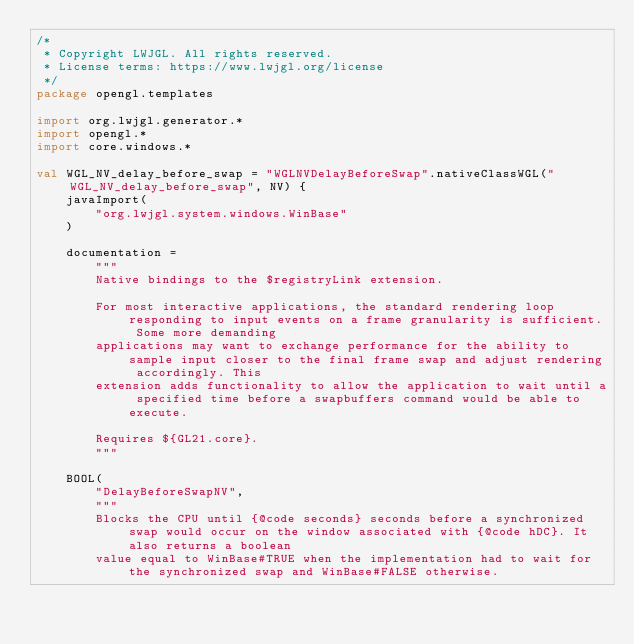<code> <loc_0><loc_0><loc_500><loc_500><_Kotlin_>/*
 * Copyright LWJGL. All rights reserved.
 * License terms: https://www.lwjgl.org/license
 */
package opengl.templates

import org.lwjgl.generator.*
import opengl.*
import core.windows.*

val WGL_NV_delay_before_swap = "WGLNVDelayBeforeSwap".nativeClassWGL("WGL_NV_delay_before_swap", NV) {
    javaImport(
        "org.lwjgl.system.windows.WinBase"
    )

    documentation =
        """
        Native bindings to the $registryLink extension.

        For most interactive applications, the standard rendering loop responding to input events on a frame granularity is sufficient. Some more demanding
        applications may want to exchange performance for the ability to sample input closer to the final frame swap and adjust rendering accordingly. This
        extension adds functionality to allow the application to wait until a specified time before a swapbuffers command would be able to execute.

        Requires ${GL21.core}.
        """

    BOOL(
        "DelayBeforeSwapNV",
        """
        Blocks the CPU until {@code seconds} seconds before a synchronized swap would occur on the window associated with {@code hDC}. It also returns a boolean
        value equal to WinBase#TRUE when the implementation had to wait for the synchronized swap and WinBase#FALSE otherwise.
  </code> 